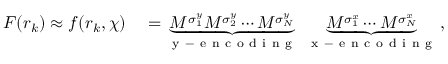<formula> <loc_0><loc_0><loc_500><loc_500>\begin{array} { r l } { F ( r _ { k } ) \approx f ( r _ { k } , \chi ) } & = \underbrace { M ^ { \sigma _ { 1 } ^ { y } } M ^ { \sigma _ { 2 } ^ { y } } \cdots M ^ { \sigma _ { N } ^ { y } } } _ { y - e n c o d i n g } \, \underbrace { M ^ { \sigma _ { 1 } ^ { x } } \cdots M ^ { \sigma _ { N } ^ { x } } } _ { x - e n c o d i n g } \, , } \end{array}</formula> 